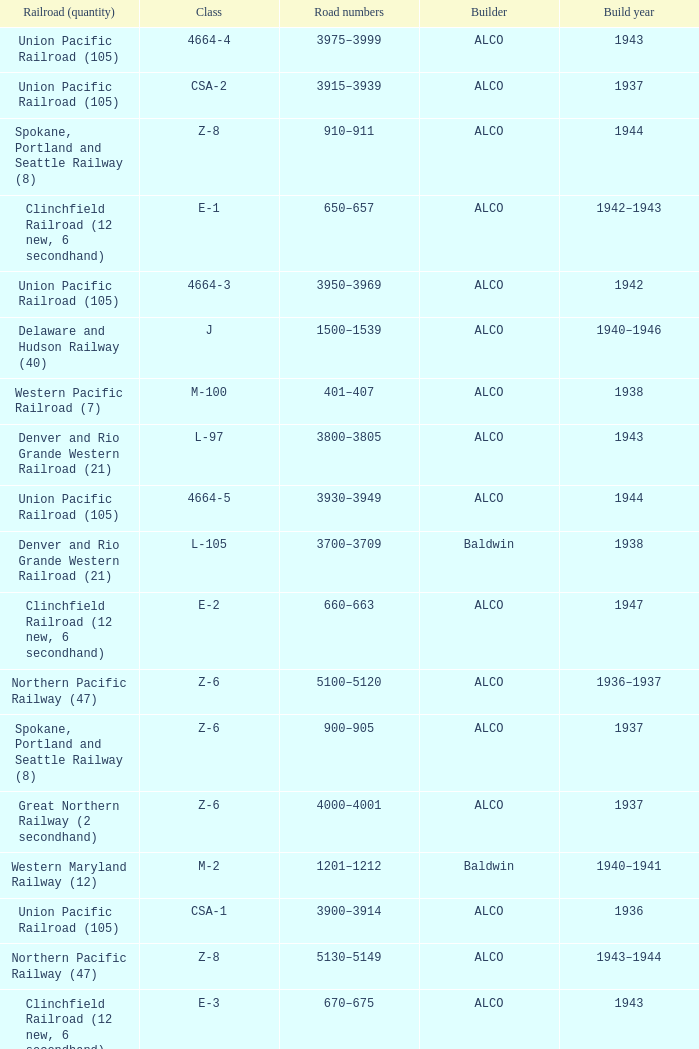What is the road numbers when the build year is 1943, the railroad (quantity) is clinchfield railroad (12 new, 6 secondhand)? 670–675. 